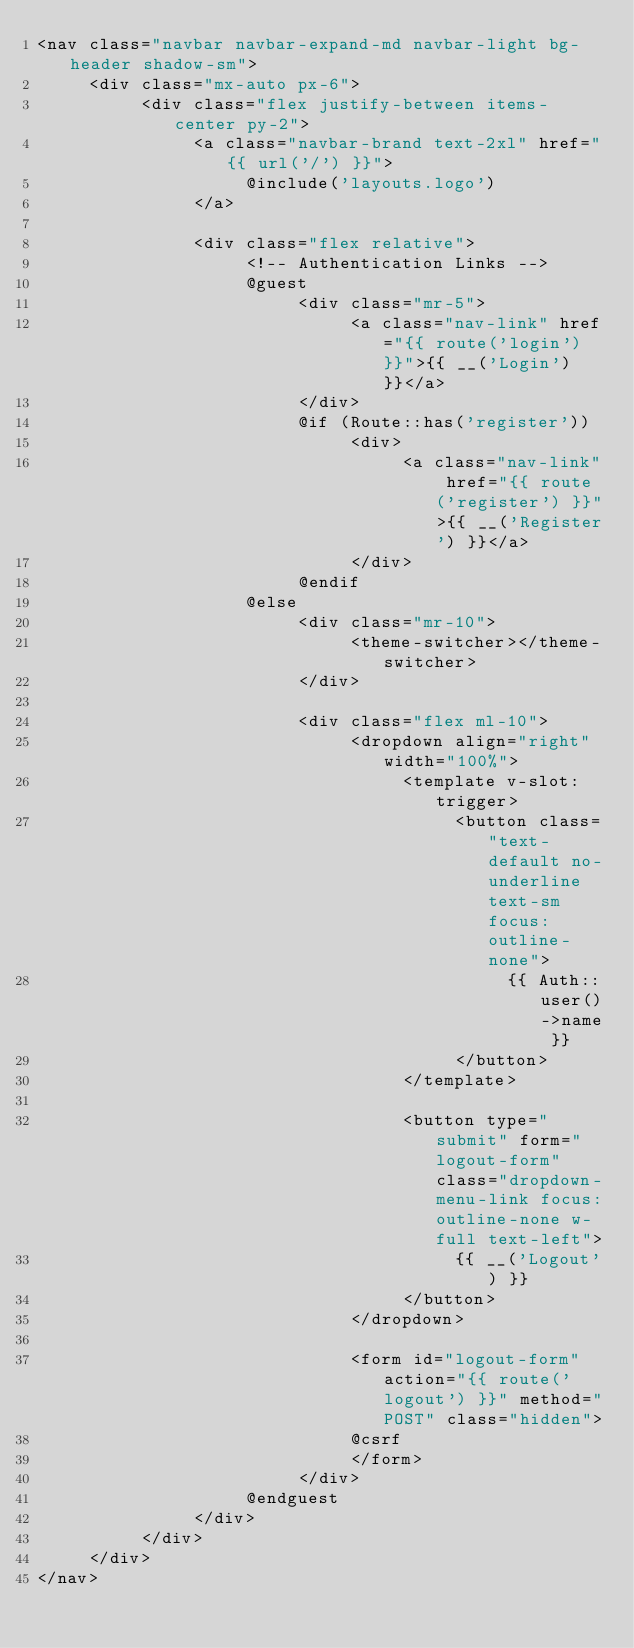Convert code to text. <code><loc_0><loc_0><loc_500><loc_500><_PHP_><nav class="navbar navbar-expand-md navbar-light bg-header shadow-sm">
     <div class="mx-auto px-6">
          <div class="flex justify-between items-center py-2">
               <a class="navbar-brand text-2xl" href="{{ url('/') }}">
                    @include('layouts.logo')
               </a>
          
               <div class="flex relative">
                    <!-- Authentication Links -->
                    @guest
                         <div class="mr-5">
                              <a class="nav-link" href="{{ route('login') }}">{{ __('Login') }}</a>
                         </div>
                         @if (Route::has('register'))
                              <div>
                                   <a class="nav-link" href="{{ route('register') }}">{{ __('Register') }}</a>
                              </div>
                         @endif
                    @else
                         <div class="mr-10">
                              <theme-switcher></theme-switcher>
                         </div>

                         <div class="flex ml-10">
                              <dropdown align="right" width="100%">
                                   <template v-slot:trigger>
                                        <button class="text-default no-underline text-sm focus:outline-none">
                                             {{ Auth::user()->name }}
                                        </button>
                                   </template>

                                   <button type="submit" form="logout-form" class="dropdown-menu-link focus:outline-none w-full text-left">
                                        {{ __('Logout') }}
                                   </button>
                              </dropdown>
          
                              <form id="logout-form" action="{{ route('logout') }}" method="POST" class="hidden">
                              @csrf
                              </form>
                         </div>
                    @endguest
               </div>
          </div>
     </div>
</nav>
</code> 